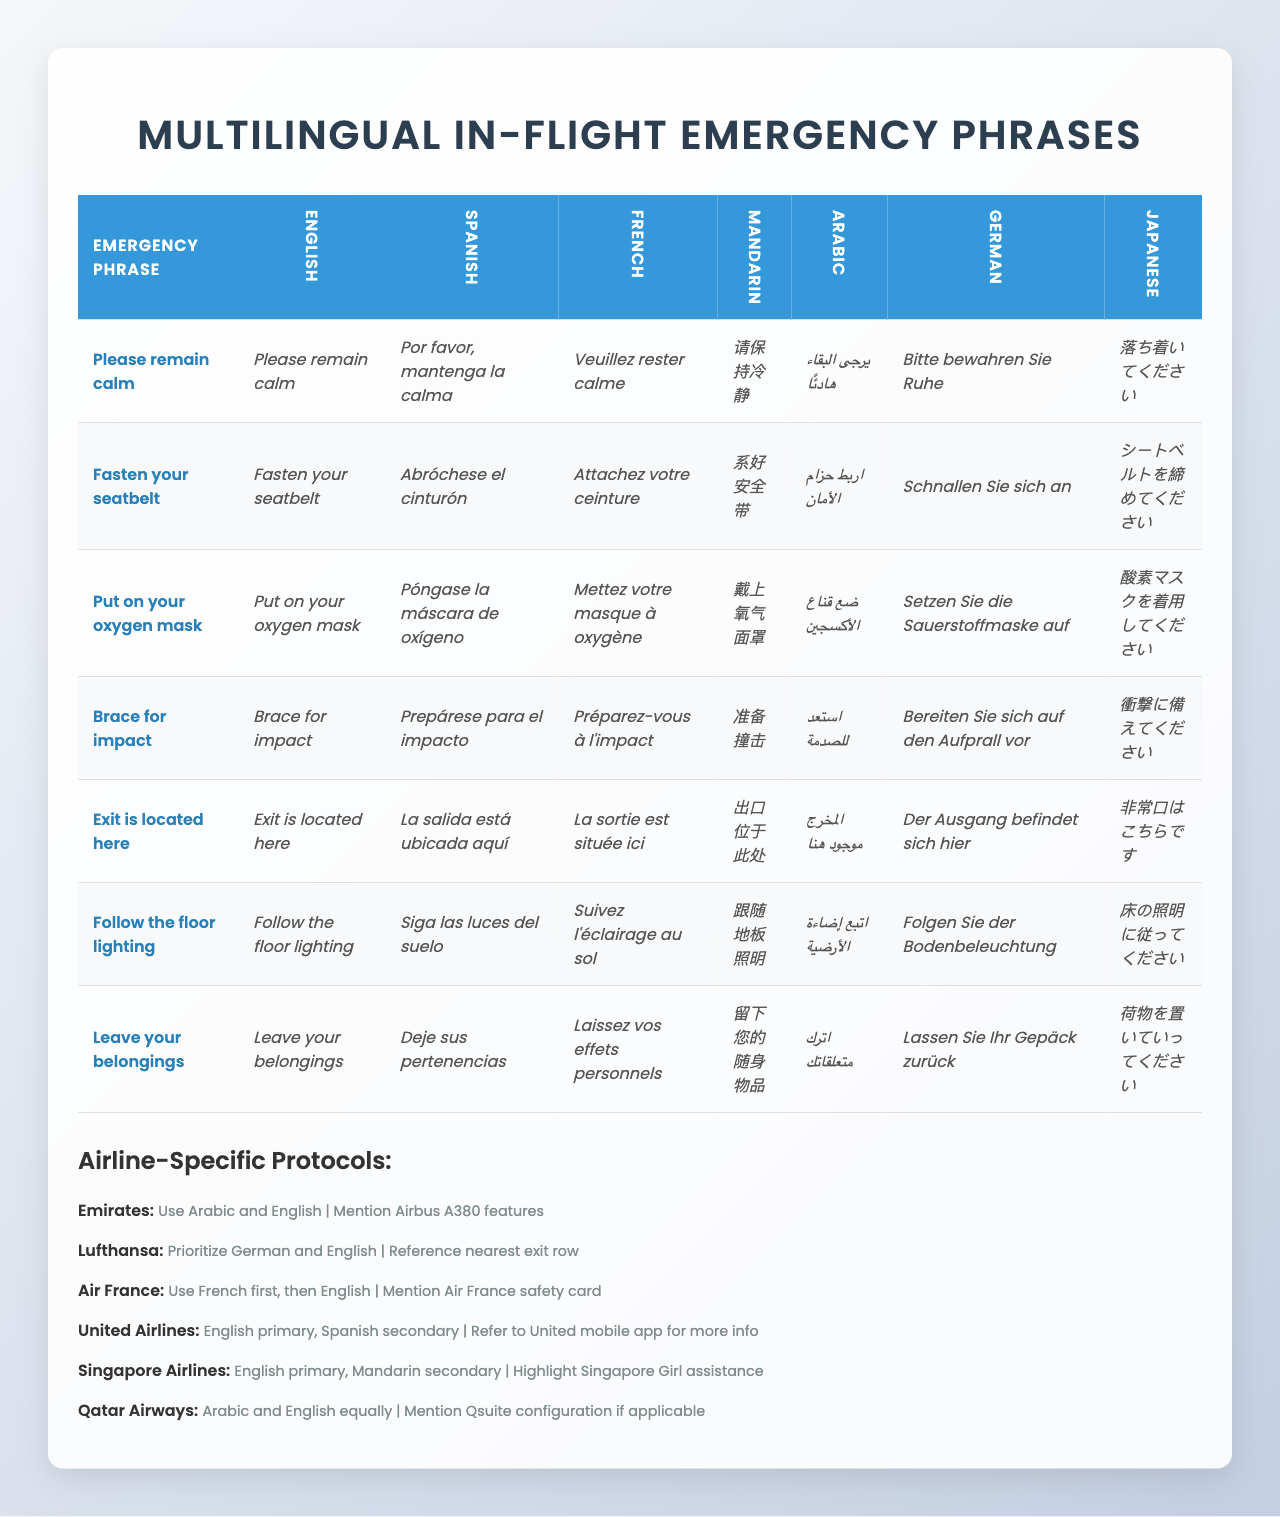What is the Spanish translation for "Fasten your seatbelt"? The Spanish translation can be found in the row corresponding to "Fasten your seatbelt" under the Spanish column which is "Abróchese el cinturón".
Answer: Abróchese el cinturón Which airline prioritizes the use of German? In the "Airline-Specific Protocols" section, Lufthansa is mentioned as prioritizing German and English.
Answer: Lufthansa How many emergency phrases are listed in the table? The table lists a total of 7 emergency phrases. This can be counted from the rows in the "Emergency Phrase" column.
Answer: 7 Is the phrase "Leave your belongings" translated into Arabic in the table? Yes, the phrase "Leave your belongings" is translated into Arabic as "اترك متعلقاتك". This can be verified by checking the Arabic column corresponding to that phrase.
Answer: Yes What are the two primary languages used by Qatar Airways in emergencies? Qatar Airways uses Arabic and English equally as indicated in the airline-specific protocols.
Answer: Arabic and English Which language has the phrase "请保持冷静" and what does it mean in English? The phrase "请保持冷静" is in Mandarin, and it translates to "Please remain calm" in English. This is found by locating the phrase in the Mandarin translations.
Answer: Please remain calm If you combine the number of airlines that use Arabic and those that use Spanish primarily, how many total airlines does that account for? Qatar Airways and Emirates use Arabic, while United Airlines uses Spanish as a secondary language, but English is primary for United. Since Qatar and Emirates are two airlines that use Arabic primarily, the total would be 2 for Arabic and 1 for Spanish. Thus, 2 + 1 = 3 airlines.
Answer: 3 Does Air France reference the use of an Air France safety card? Yes, the protocols mention that Air France references the Air France safety card. This can be checked in the Airline-Specific Protocols section for Air France.
Answer: Yes Which emergency phrase has the same translation in both English and Mandarin? The phrase "Fasten your seatbelt" translates to "系好安全带" in Mandarin and remains consistent across translations. Checking both languages confirms this translation match.
Answer: Fasten your seatbelt How many phrases have different translations between French and Spanish? If we compare the translations of the phrases in French and Spanish, we find that all 7 phrases have different translations, meaning every phrase varies between the two languages.
Answer: 7 What is the specific emergency instruction that is translated as "سوف تكون هنا" in Arabic? The phrase "سوف تكون هنا" does not appear in the table; instead, "Exit is located here" translates to "المخرج موجود هنا" in Arabic. Thus, "سوف تكون هنا" is not a valid translation for any listed phrase.
Answer: Not applicable 